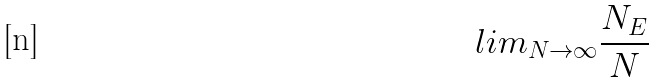<formula> <loc_0><loc_0><loc_500><loc_500>l i m _ { N \rightarrow \infty } \frac { N _ { E } } { N }</formula> 